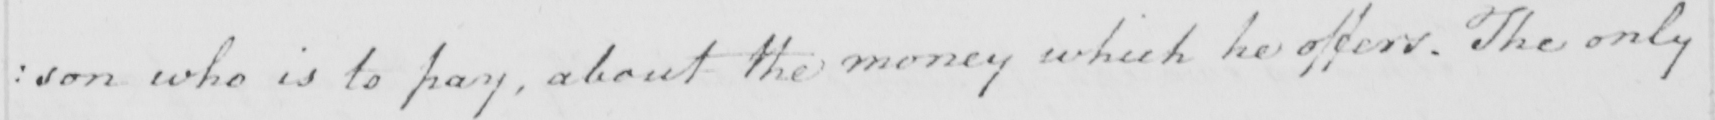What text is written in this handwritten line? : son who is to pay , about the money which he offers . The only 